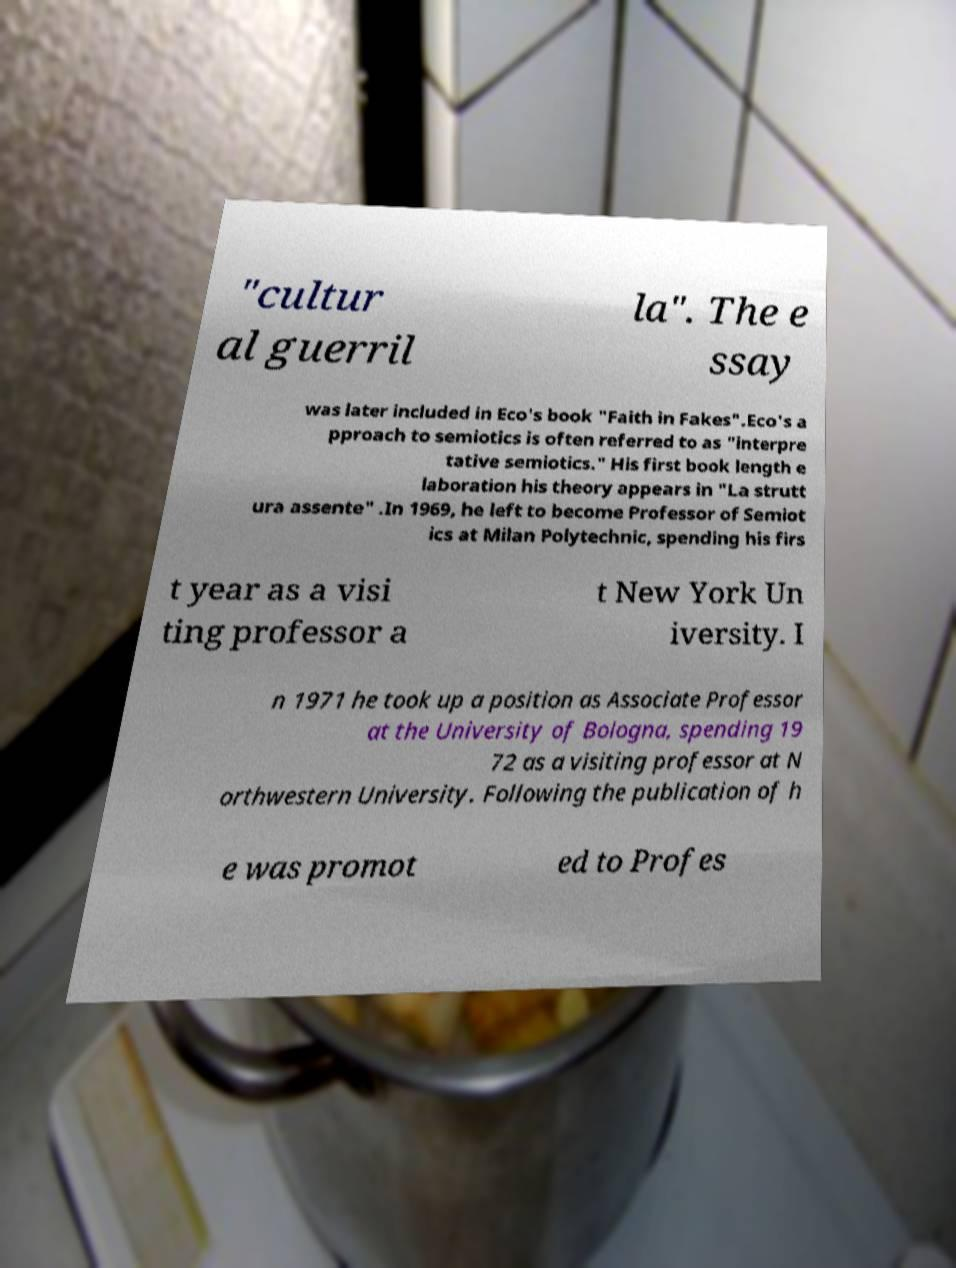Please read and relay the text visible in this image. What does it say? "cultur al guerril la". The e ssay was later included in Eco's book "Faith in Fakes".Eco's a pproach to semiotics is often referred to as "interpre tative semiotics." His first book length e laboration his theory appears in "La strutt ura assente" .In 1969, he left to become Professor of Semiot ics at Milan Polytechnic, spending his firs t year as a visi ting professor a t New York Un iversity. I n 1971 he took up a position as Associate Professor at the University of Bologna, spending 19 72 as a visiting professor at N orthwestern University. Following the publication of h e was promot ed to Profes 